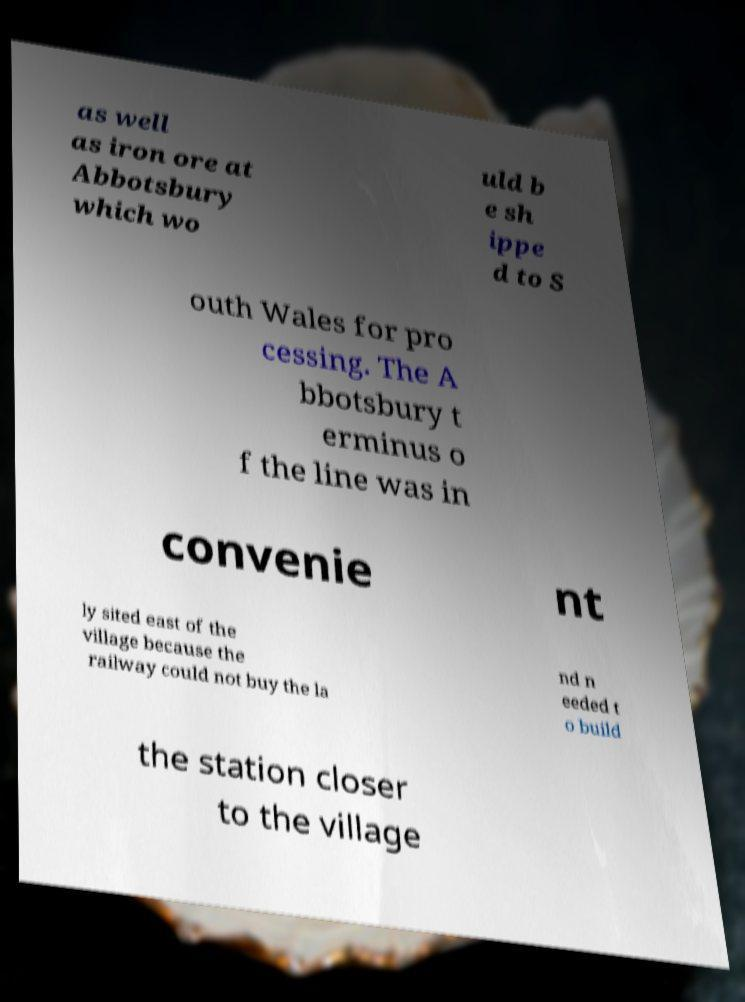Could you assist in decoding the text presented in this image and type it out clearly? as well as iron ore at Abbotsbury which wo uld b e sh ippe d to S outh Wales for pro cessing. The A bbotsbury t erminus o f the line was in convenie nt ly sited east of the village because the railway could not buy the la nd n eeded t o build the station closer to the village 